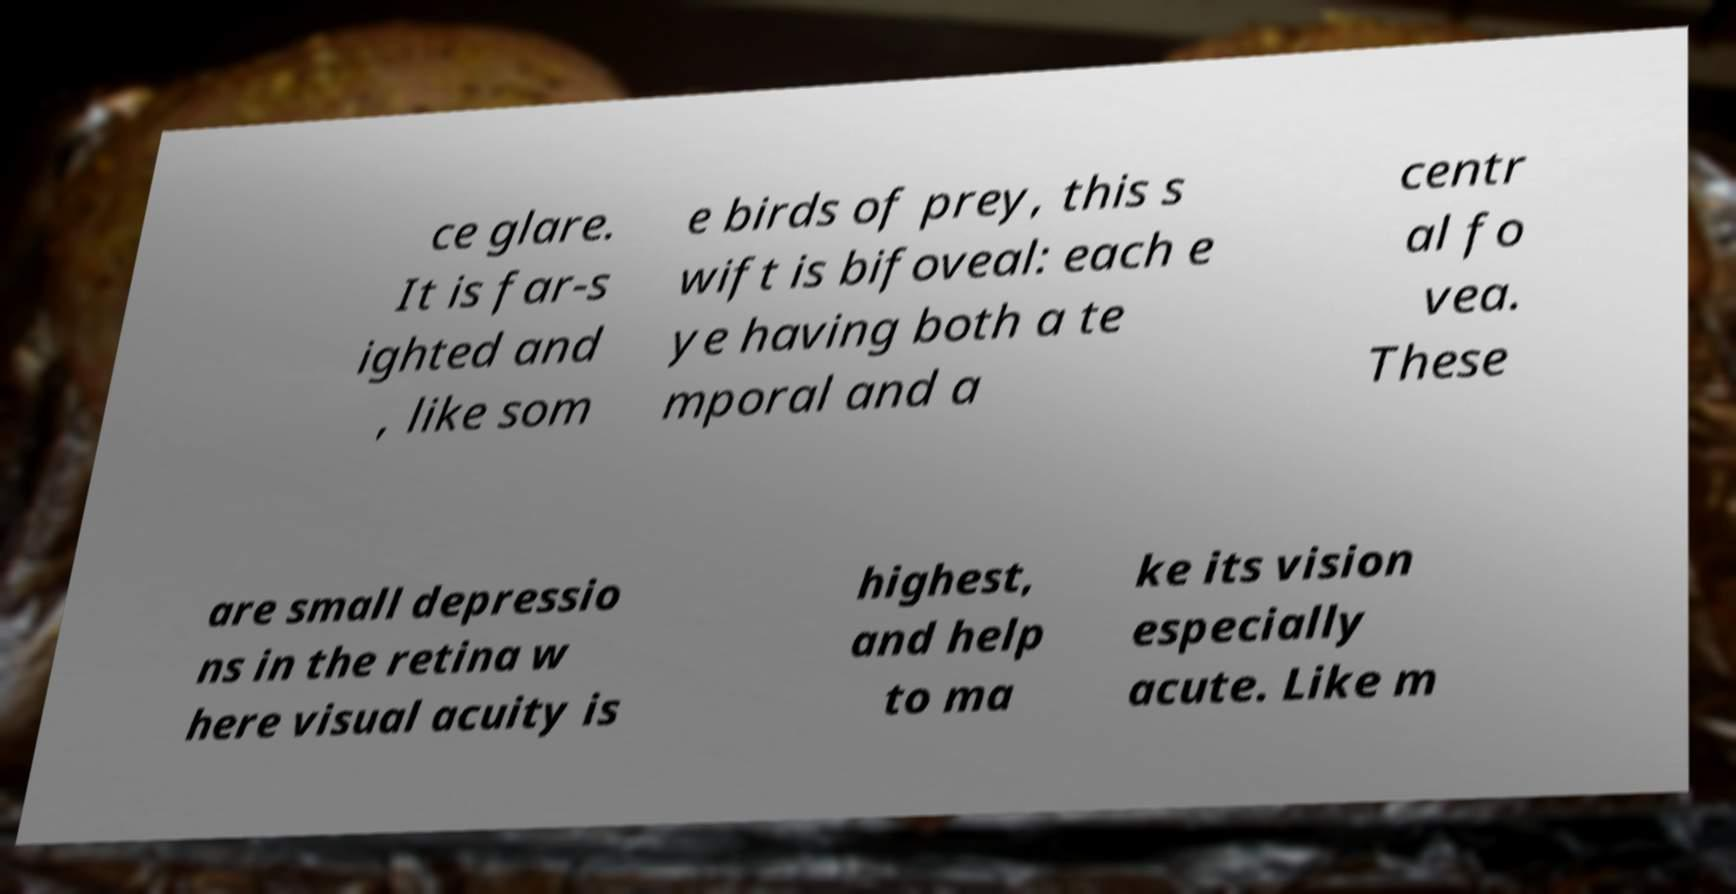I need the written content from this picture converted into text. Can you do that? ce glare. It is far-s ighted and , like som e birds of prey, this s wift is bifoveal: each e ye having both a te mporal and a centr al fo vea. These are small depressio ns in the retina w here visual acuity is highest, and help to ma ke its vision especially acute. Like m 